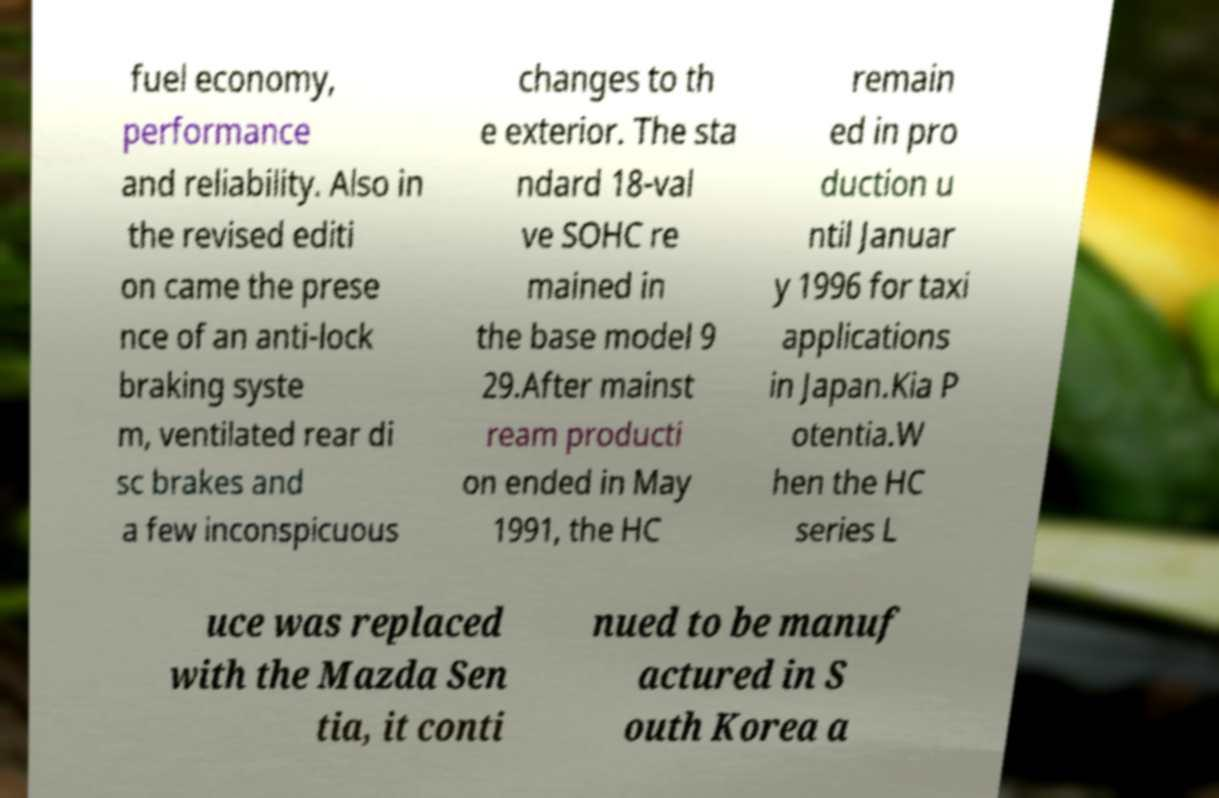I need the written content from this picture converted into text. Can you do that? fuel economy, performance and reliability. Also in the revised editi on came the prese nce of an anti-lock braking syste m, ventilated rear di sc brakes and a few inconspicuous changes to th e exterior. The sta ndard 18-val ve SOHC re mained in the base model 9 29.After mainst ream producti on ended in May 1991, the HC remain ed in pro duction u ntil Januar y 1996 for taxi applications in Japan.Kia P otentia.W hen the HC series L uce was replaced with the Mazda Sen tia, it conti nued to be manuf actured in S outh Korea a 